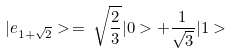Convert formula to latex. <formula><loc_0><loc_0><loc_500><loc_500>| e _ { 1 + \sqrt { 2 } } > \, = \, \sqrt { \frac { 2 } { 3 } } | 0 > + \frac { 1 } { \sqrt { 3 } } | 1 ></formula> 